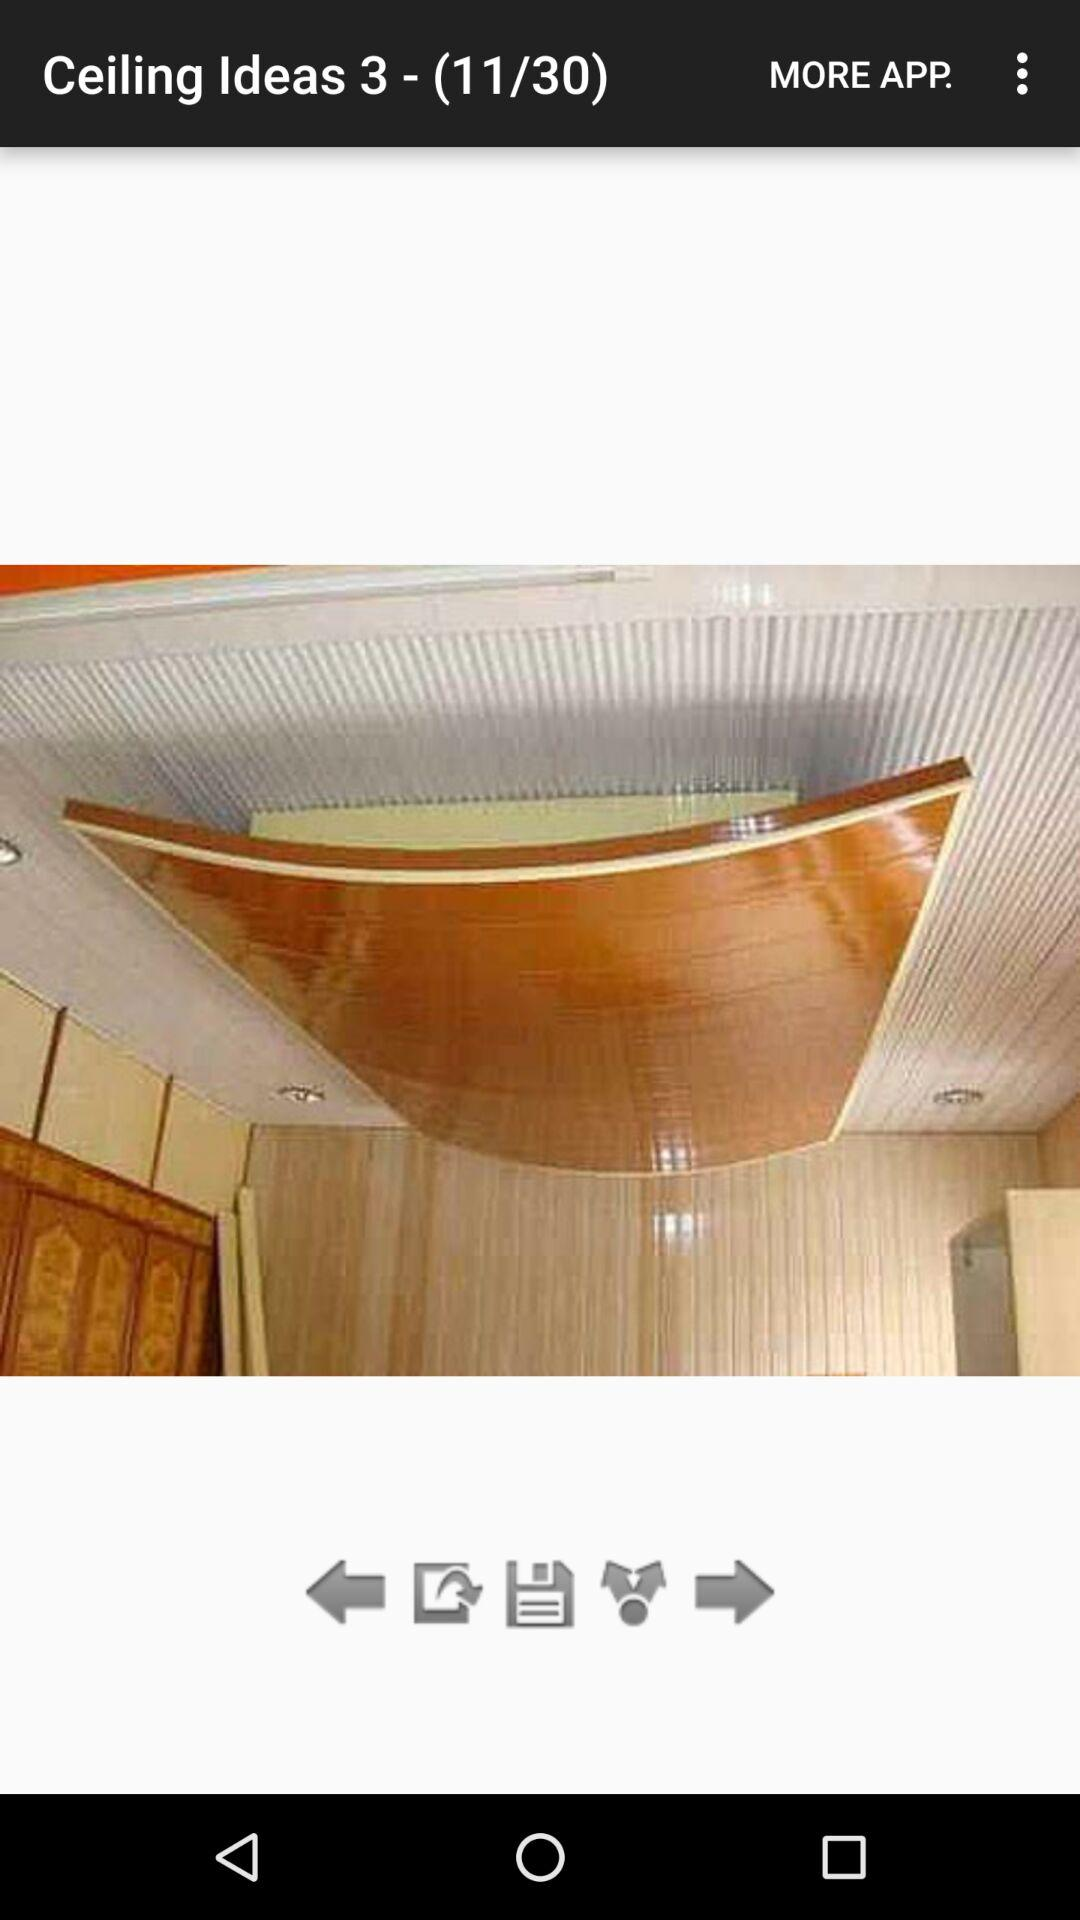What is the total number of images? The total number of images is 30. 